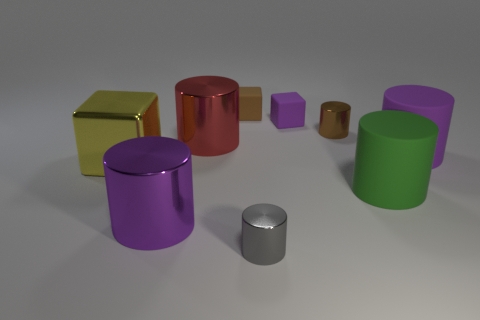Subtract all purple cylinders. How many cylinders are left? 4 Subtract all small cylinders. How many cylinders are left? 4 Add 1 cylinders. How many objects exist? 10 Subtract all green cylinders. Subtract all gray balls. How many cylinders are left? 5 Subtract all cubes. How many objects are left? 6 Add 6 tiny green cylinders. How many tiny green cylinders exist? 6 Subtract 1 purple blocks. How many objects are left? 8 Subtract all yellow matte cylinders. Subtract all tiny brown things. How many objects are left? 7 Add 5 brown cylinders. How many brown cylinders are left? 6 